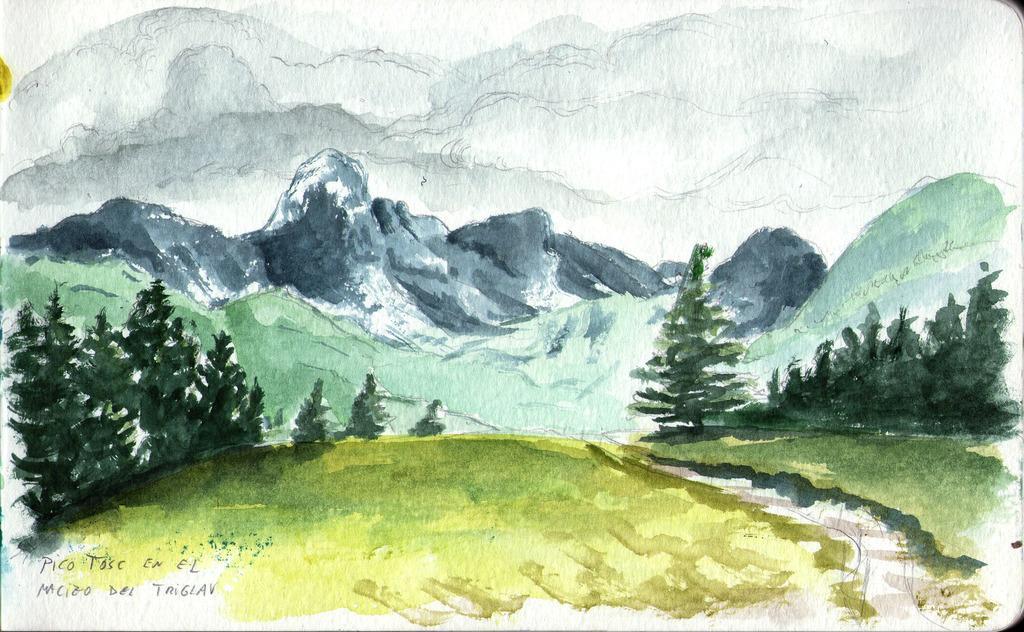Could you give a brief overview of what you see in this image? In this picture we can see painting of trees, mountain and sky. In the bottom left side of the image we can see some text. 